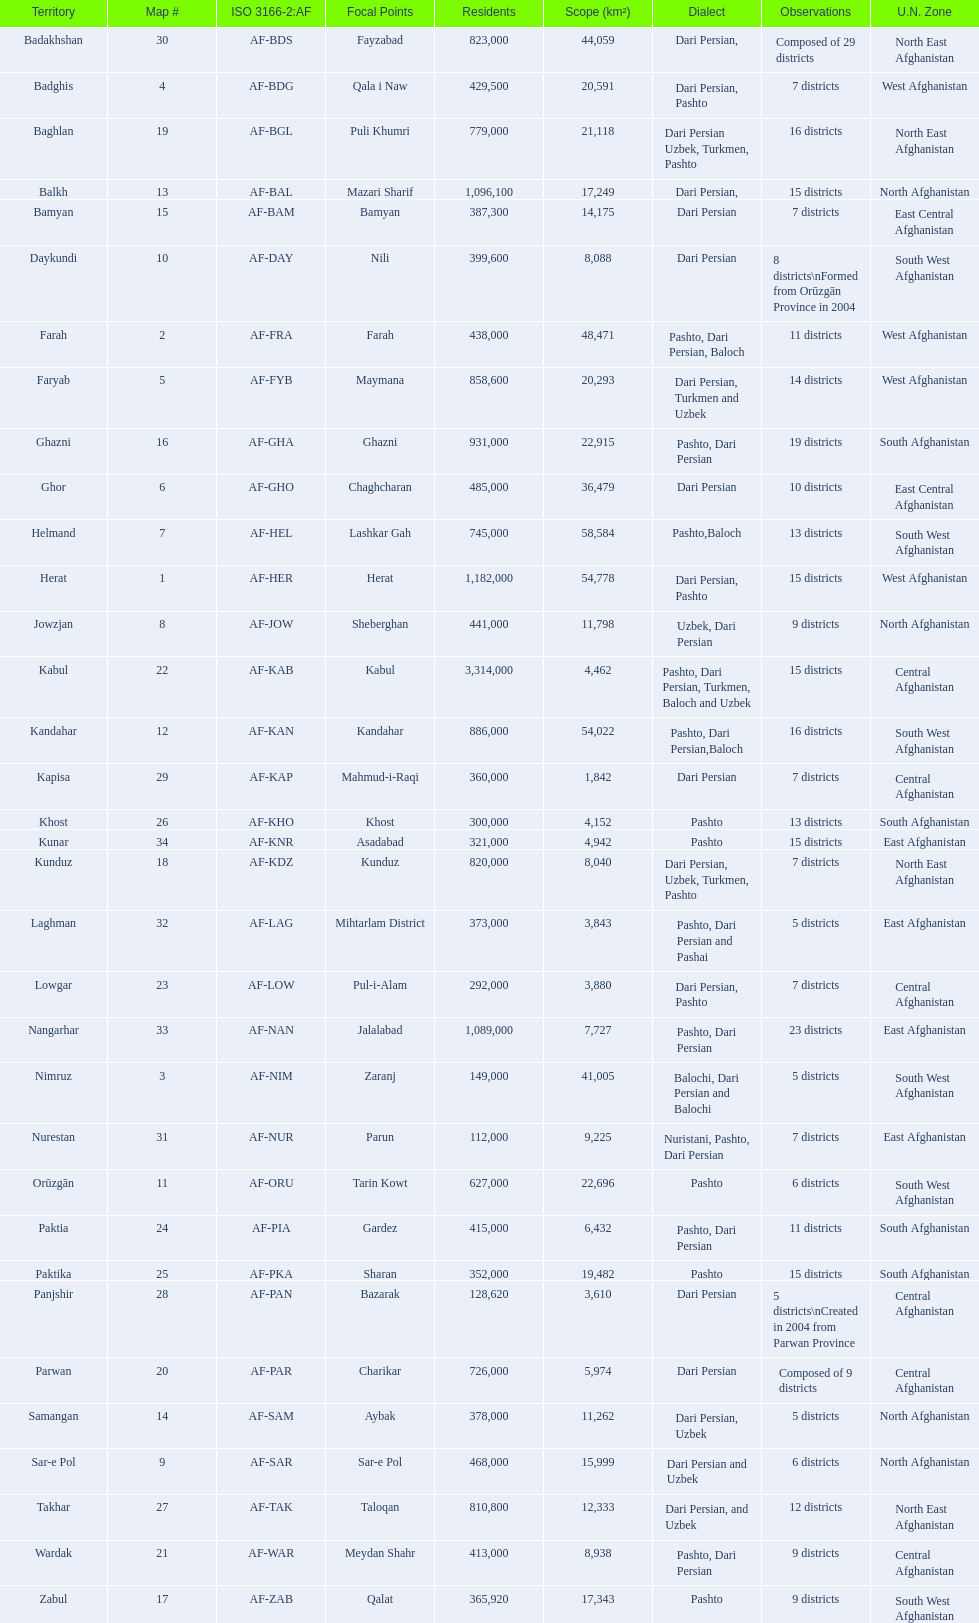Does ghor or farah have more districts? Farah. 